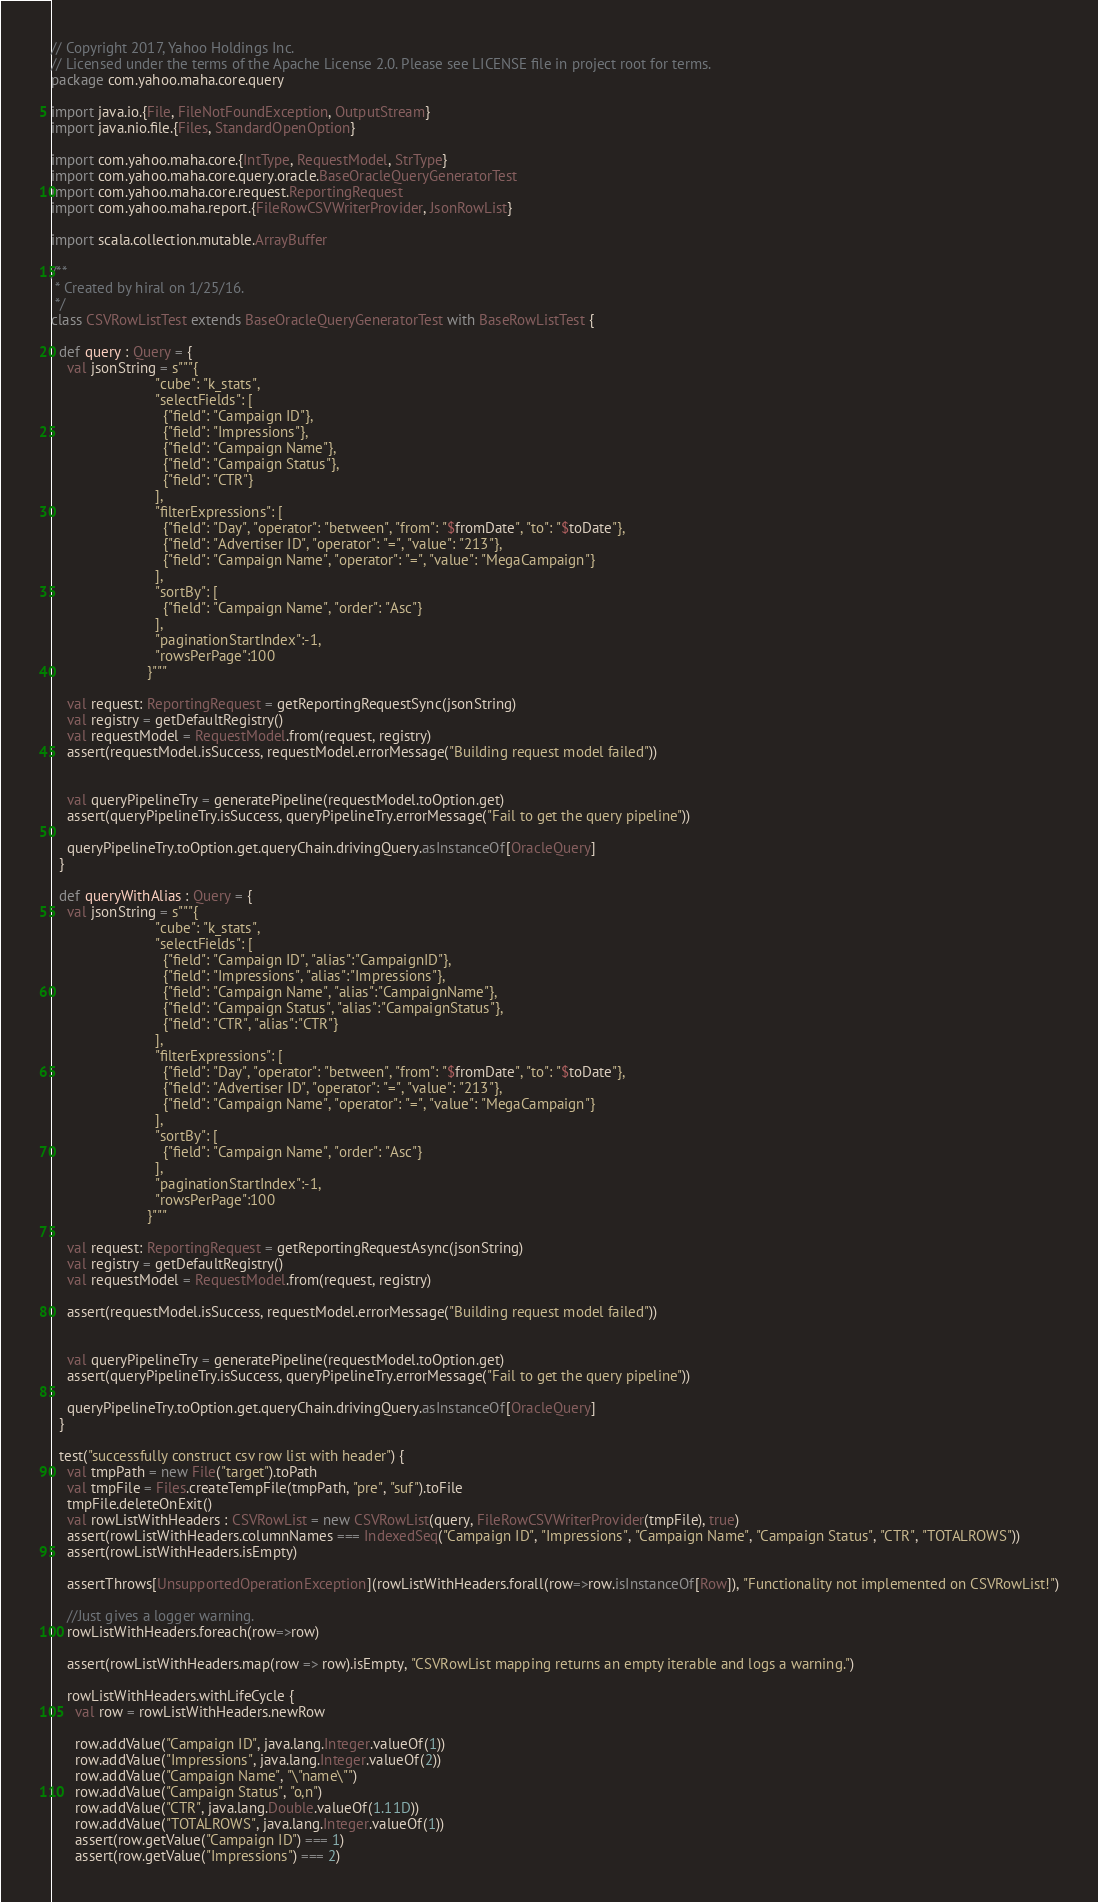Convert code to text. <code><loc_0><loc_0><loc_500><loc_500><_Scala_>// Copyright 2017, Yahoo Holdings Inc.
// Licensed under the terms of the Apache License 2.0. Please see LICENSE file in project root for terms.
package com.yahoo.maha.core.query

import java.io.{File, FileNotFoundException, OutputStream}
import java.nio.file.{Files, StandardOpenOption}

import com.yahoo.maha.core.{IntType, RequestModel, StrType}
import com.yahoo.maha.core.query.oracle.BaseOracleQueryGeneratorTest
import com.yahoo.maha.core.request.ReportingRequest
import com.yahoo.maha.report.{FileRowCSVWriterProvider, JsonRowList}

import scala.collection.mutable.ArrayBuffer

/**
 * Created by hiral on 1/25/16.
 */
class CSVRowListTest extends BaseOracleQueryGeneratorTest with BaseRowListTest {

  def query : Query = {
    val jsonString = s"""{
                          "cube": "k_stats",
                          "selectFields": [
                            {"field": "Campaign ID"},
                            {"field": "Impressions"},
                            {"field": "Campaign Name"},
                            {"field": "Campaign Status"},
                            {"field": "CTR"}
                          ],
                          "filterExpressions": [
                            {"field": "Day", "operator": "between", "from": "$fromDate", "to": "$toDate"},
                            {"field": "Advertiser ID", "operator": "=", "value": "213"},
                            {"field": "Campaign Name", "operator": "=", "value": "MegaCampaign"}
                          ],
                          "sortBy": [
                            {"field": "Campaign Name", "order": "Asc"}
                          ],
                          "paginationStartIndex":-1,
                          "rowsPerPage":100
                        }"""

    val request: ReportingRequest = getReportingRequestSync(jsonString)
    val registry = getDefaultRegistry()
    val requestModel = RequestModel.from(request, registry)
    assert(requestModel.isSuccess, requestModel.errorMessage("Building request model failed"))


    val queryPipelineTry = generatePipeline(requestModel.toOption.get)
    assert(queryPipelineTry.isSuccess, queryPipelineTry.errorMessage("Fail to get the query pipeline"))

    queryPipelineTry.toOption.get.queryChain.drivingQuery.asInstanceOf[OracleQuery]
  }

  def queryWithAlias : Query = {
    val jsonString = s"""{
                          "cube": "k_stats",
                          "selectFields": [
                            {"field": "Campaign ID", "alias":"CampaignID"},
                            {"field": "Impressions", "alias":"Impressions"},
                            {"field": "Campaign Name", "alias":"CampaignName"},
                            {"field": "Campaign Status", "alias":"CampaignStatus"},
                            {"field": "CTR", "alias":"CTR"}
                          ],
                          "filterExpressions": [
                            {"field": "Day", "operator": "between", "from": "$fromDate", "to": "$toDate"},
                            {"field": "Advertiser ID", "operator": "=", "value": "213"},
                            {"field": "Campaign Name", "operator": "=", "value": "MegaCampaign"}
                          ],
                          "sortBy": [
                            {"field": "Campaign Name", "order": "Asc"}
                          ],
                          "paginationStartIndex":-1,
                          "rowsPerPage":100
                        }"""

    val request: ReportingRequest = getReportingRequestAsync(jsonString)
    val registry = getDefaultRegistry()
    val requestModel = RequestModel.from(request, registry)

    assert(requestModel.isSuccess, requestModel.errorMessage("Building request model failed"))


    val queryPipelineTry = generatePipeline(requestModel.toOption.get)
    assert(queryPipelineTry.isSuccess, queryPipelineTry.errorMessage("Fail to get the query pipeline"))

    queryPipelineTry.toOption.get.queryChain.drivingQuery.asInstanceOf[OracleQuery]
  }

  test("successfully construct csv row list with header") {
    val tmpPath = new File("target").toPath
    val tmpFile = Files.createTempFile(tmpPath, "pre", "suf").toFile
    tmpFile.deleteOnExit()
    val rowListWithHeaders : CSVRowList = new CSVRowList(query, FileRowCSVWriterProvider(tmpFile), true)
    assert(rowListWithHeaders.columnNames === IndexedSeq("Campaign ID", "Impressions", "Campaign Name", "Campaign Status", "CTR", "TOTALROWS"))
    assert(rowListWithHeaders.isEmpty)

    assertThrows[UnsupportedOperationException](rowListWithHeaders.forall(row=>row.isInstanceOf[Row]), "Functionality not implemented on CSVRowList!")

    //Just gives a logger warning.
    rowListWithHeaders.foreach(row=>row)

    assert(rowListWithHeaders.map(row => row).isEmpty, "CSVRowList mapping returns an empty iterable and logs a warning.")

    rowListWithHeaders.withLifeCycle {
      val row = rowListWithHeaders.newRow

      row.addValue("Campaign ID", java.lang.Integer.valueOf(1))
      row.addValue("Impressions", java.lang.Integer.valueOf(2))
      row.addValue("Campaign Name", "\"name\"")
      row.addValue("Campaign Status", "o,n")
      row.addValue("CTR", java.lang.Double.valueOf(1.11D))
      row.addValue("TOTALROWS", java.lang.Integer.valueOf(1))
      assert(row.getValue("Campaign ID") === 1)
      assert(row.getValue("Impressions") === 2)</code> 